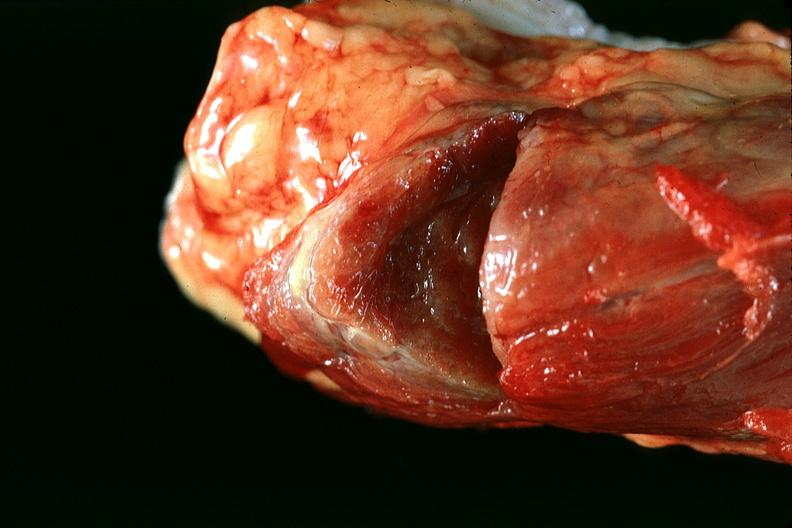does this image show thyroid, normal?
Answer the question using a single word or phrase. Yes 